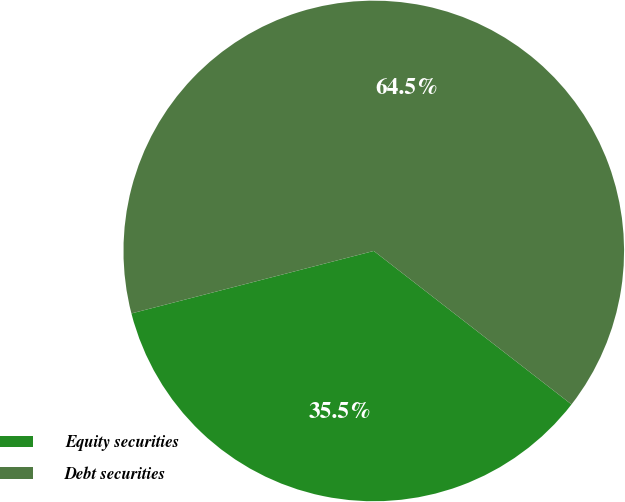Convert chart. <chart><loc_0><loc_0><loc_500><loc_500><pie_chart><fcel>Equity securities<fcel>Debt securities<nl><fcel>35.48%<fcel>64.52%<nl></chart> 